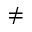<formula> <loc_0><loc_0><loc_500><loc_500>\neq</formula> 